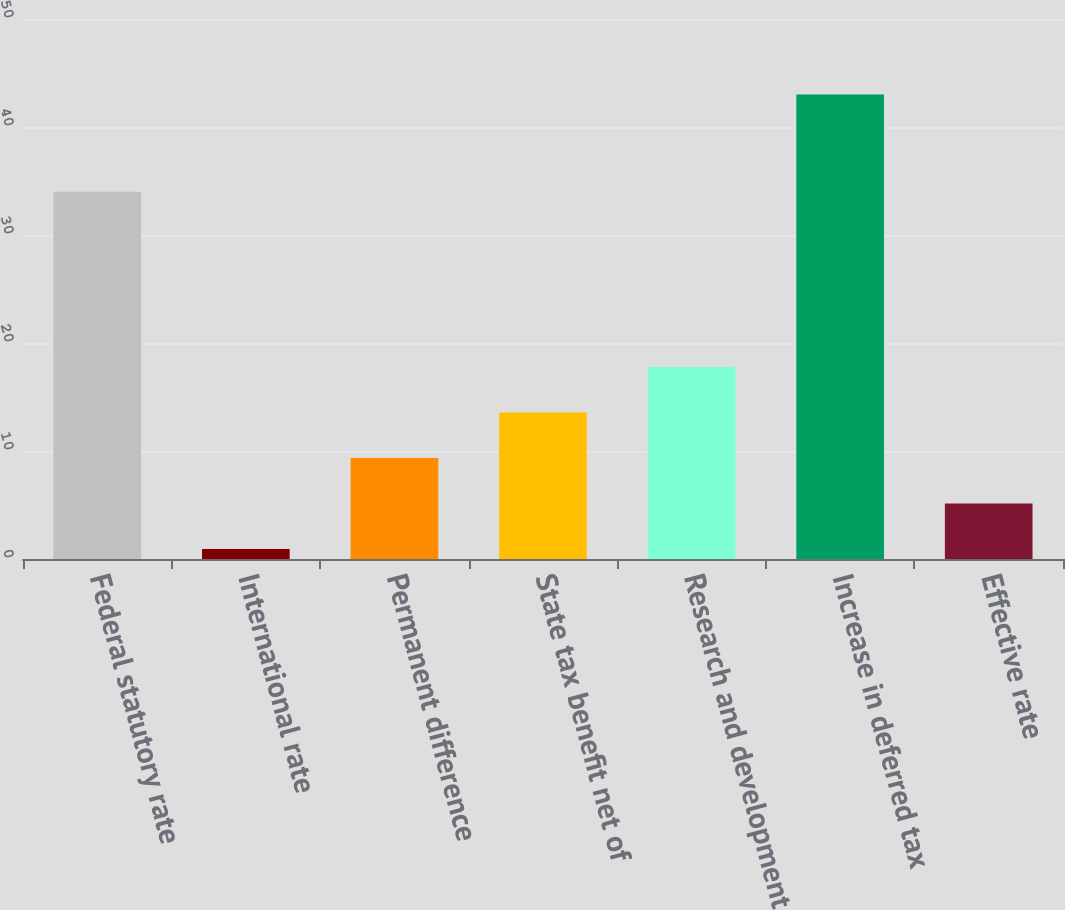Convert chart to OTSL. <chart><loc_0><loc_0><loc_500><loc_500><bar_chart><fcel>Federal statutory rate<fcel>International rate<fcel>Permanent difference<fcel>State tax benefit net of<fcel>Research and development<fcel>Increase in deferred tax<fcel>Effective rate<nl><fcel>34<fcel>0.93<fcel>9.35<fcel>13.56<fcel>17.77<fcel>43<fcel>5.14<nl></chart> 